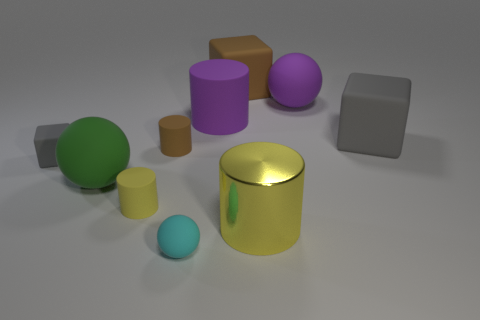Subtract 1 cylinders. How many cylinders are left? 3 Subtract all balls. How many objects are left? 7 Add 5 metallic cubes. How many metallic cubes exist? 5 Subtract 0 gray cylinders. How many objects are left? 10 Subtract all matte cubes. Subtract all tiny cylinders. How many objects are left? 5 Add 8 gray matte cubes. How many gray matte cubes are left? 10 